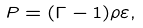<formula> <loc_0><loc_0><loc_500><loc_500>P = ( \Gamma - 1 ) \rho \varepsilon ,</formula> 